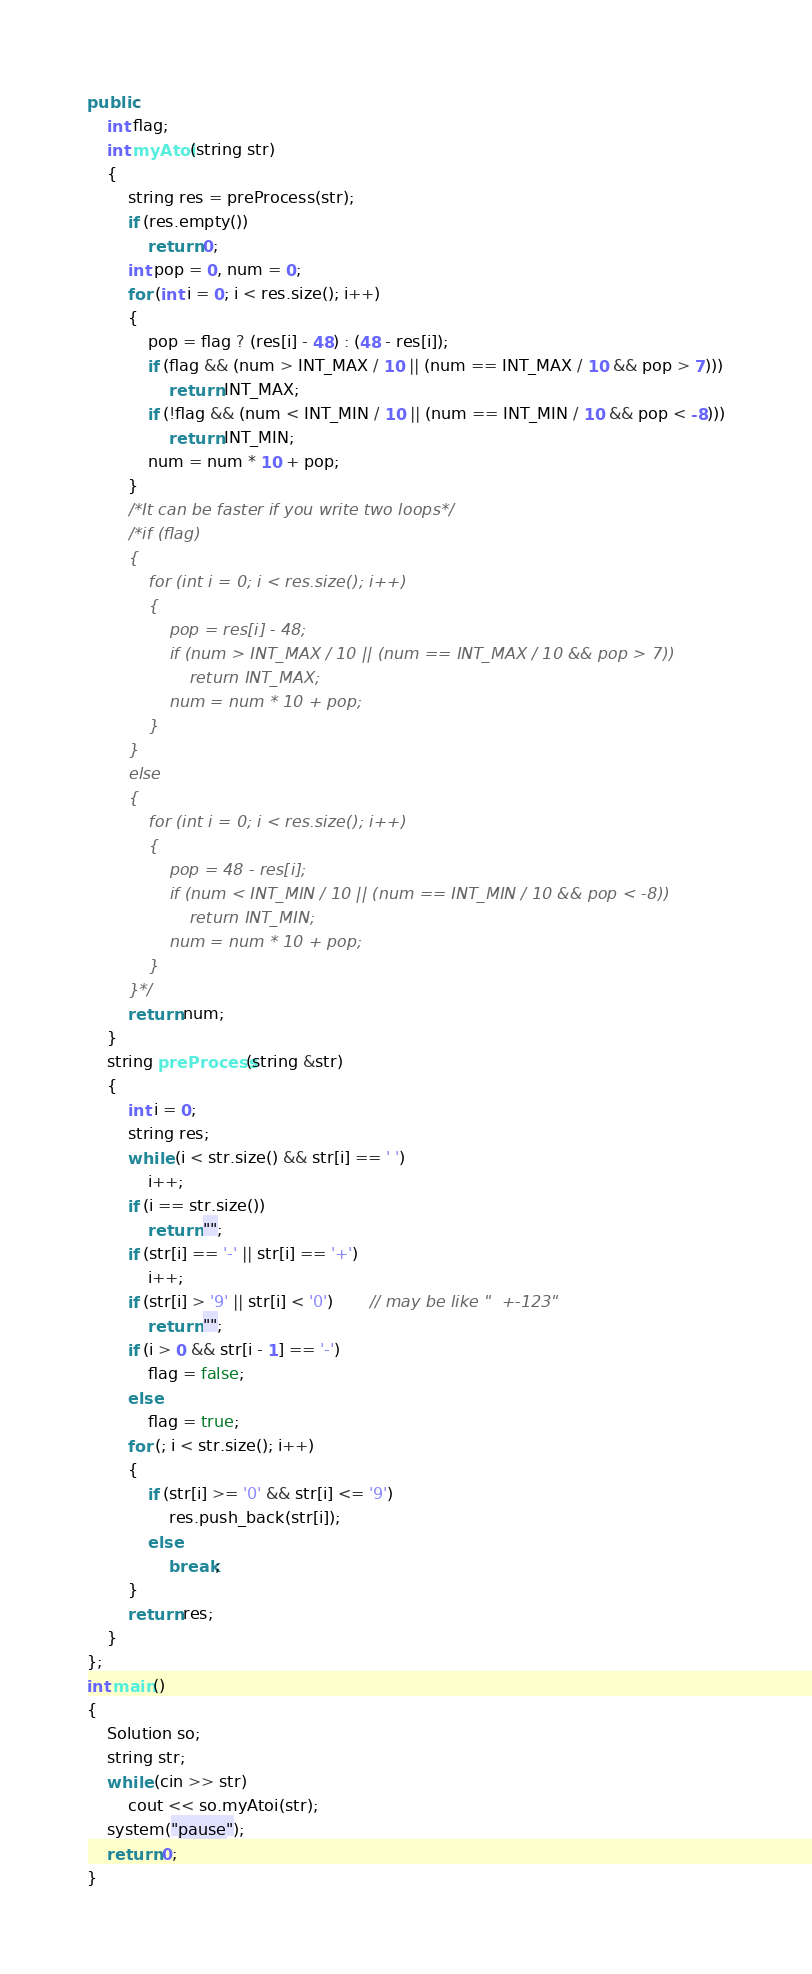Convert code to text. <code><loc_0><loc_0><loc_500><loc_500><_C++_>public:
    int flag;
    int myAtoi(string str)
    {
        string res = preProcess(str);
        if (res.empty())
            return 0;
        int pop = 0, num = 0;
        for (int i = 0; i < res.size(); i++)
        {
            pop = flag ? (res[i] - 48) : (48 - res[i]);
            if (flag && (num > INT_MAX / 10 || (num == INT_MAX / 10 && pop > 7)))
                return INT_MAX;
            if (!flag && (num < INT_MIN / 10 || (num == INT_MIN / 10 && pop < -8)))
                return INT_MIN;
            num = num * 10 + pop;
        }
        /*It can be faster if you write two loops*/
        /*if (flag)
        {
            for (int i = 0; i < res.size(); i++)
            {
                pop = res[i] - 48;
                if (num > INT_MAX / 10 || (num == INT_MAX / 10 && pop > 7))
                    return INT_MAX;
                num = num * 10 + pop;
            }
        }
        else
        {
            for (int i = 0; i < res.size(); i++)
            {
                pop = 48 - res[i];
                if (num < INT_MIN / 10 || (num == INT_MIN / 10 && pop < -8))
                    return INT_MIN;
                num = num * 10 + pop;
            }
        }*/
        return num;
    }
    string preProcess(string &str)
    {
        int i = 0;
        string res;
        while (i < str.size() && str[i] == ' ')
            i++;
        if (i == str.size())
            return "";
        if (str[i] == '-' || str[i] == '+')
            i++;
        if (str[i] > '9' || str[i] < '0')       // may be like "  +-123"
            return "";
        if (i > 0 && str[i - 1] == '-')     
            flag = false;
        else
            flag = true;
        for (; i < str.size(); i++)
        {
            if (str[i] >= '0' && str[i] <= '9')
                res.push_back(str[i]);
            else
                break;
        }
        return res;
    }
};
int main()
{
    Solution so;
    string str;
    while (cin >> str)
        cout << so.myAtoi(str);
    system("pause");
    return 0;
}</code> 